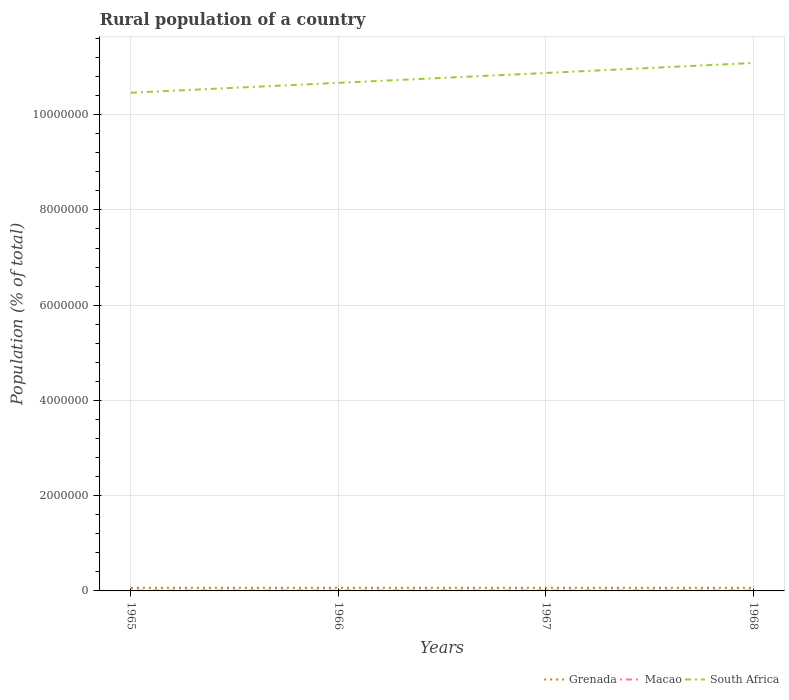How many different coloured lines are there?
Your answer should be very brief. 3. Across all years, what is the maximum rural population in South Africa?
Your answer should be compact. 1.05e+07. In which year was the rural population in South Africa maximum?
Make the answer very short. 1965. What is the total rural population in Grenada in the graph?
Ensure brevity in your answer.  366. What is the difference between the highest and the second highest rural population in Grenada?
Your response must be concise. 366. What is the difference between the highest and the lowest rural population in South Africa?
Provide a short and direct response. 2. Is the rural population in Macao strictly greater than the rural population in Grenada over the years?
Your answer should be very brief. Yes. What is the difference between two consecutive major ticks on the Y-axis?
Give a very brief answer. 2.00e+06. Are the values on the major ticks of Y-axis written in scientific E-notation?
Keep it short and to the point. No. Does the graph contain grids?
Your response must be concise. Yes. Where does the legend appear in the graph?
Your answer should be very brief. Bottom right. How are the legend labels stacked?
Make the answer very short. Horizontal. What is the title of the graph?
Give a very brief answer. Rural population of a country. Does "Sub-Saharan Africa (all income levels)" appear as one of the legend labels in the graph?
Your answer should be very brief. No. What is the label or title of the X-axis?
Offer a terse response. Years. What is the label or title of the Y-axis?
Your response must be concise. Population (% of total). What is the Population (% of total) of Grenada in 1965?
Keep it short and to the point. 6.50e+04. What is the Population (% of total) in Macao in 1965?
Make the answer very short. 7910. What is the Population (% of total) of South Africa in 1965?
Your response must be concise. 1.05e+07. What is the Population (% of total) in Grenada in 1966?
Keep it short and to the point. 6.50e+04. What is the Population (% of total) in Macao in 1966?
Keep it short and to the point. 7883. What is the Population (% of total) in South Africa in 1966?
Keep it short and to the point. 1.07e+07. What is the Population (% of total) of Grenada in 1967?
Provide a succinct answer. 6.49e+04. What is the Population (% of total) of Macao in 1967?
Give a very brief answer. 7854. What is the Population (% of total) of South Africa in 1967?
Your response must be concise. 1.09e+07. What is the Population (% of total) in Grenada in 1968?
Provide a short and direct response. 6.47e+04. What is the Population (% of total) of Macao in 1968?
Offer a very short reply. 7790. What is the Population (% of total) of South Africa in 1968?
Your answer should be very brief. 1.11e+07. Across all years, what is the maximum Population (% of total) of Grenada?
Provide a succinct answer. 6.50e+04. Across all years, what is the maximum Population (% of total) of Macao?
Keep it short and to the point. 7910. Across all years, what is the maximum Population (% of total) in South Africa?
Your response must be concise. 1.11e+07. Across all years, what is the minimum Population (% of total) of Grenada?
Keep it short and to the point. 6.47e+04. Across all years, what is the minimum Population (% of total) of Macao?
Offer a terse response. 7790. Across all years, what is the minimum Population (% of total) of South Africa?
Your response must be concise. 1.05e+07. What is the total Population (% of total) of Grenada in the graph?
Ensure brevity in your answer.  2.60e+05. What is the total Population (% of total) in Macao in the graph?
Your answer should be compact. 3.14e+04. What is the total Population (% of total) of South Africa in the graph?
Your answer should be very brief. 4.31e+07. What is the difference between the Population (% of total) in Grenada in 1965 and that in 1966?
Give a very brief answer. -25. What is the difference between the Population (% of total) in Macao in 1965 and that in 1966?
Offer a terse response. 27. What is the difference between the Population (% of total) of South Africa in 1965 and that in 1966?
Ensure brevity in your answer.  -2.07e+05. What is the difference between the Population (% of total) in Macao in 1965 and that in 1967?
Your answer should be compact. 56. What is the difference between the Population (% of total) in South Africa in 1965 and that in 1967?
Your answer should be compact. -4.15e+05. What is the difference between the Population (% of total) in Grenada in 1965 and that in 1968?
Offer a terse response. 341. What is the difference between the Population (% of total) in Macao in 1965 and that in 1968?
Your answer should be compact. 120. What is the difference between the Population (% of total) of South Africa in 1965 and that in 1968?
Provide a short and direct response. -6.25e+05. What is the difference between the Population (% of total) in Grenada in 1966 and that in 1967?
Your answer should be compact. 124. What is the difference between the Population (% of total) of Macao in 1966 and that in 1967?
Make the answer very short. 29. What is the difference between the Population (% of total) in South Africa in 1966 and that in 1967?
Offer a very short reply. -2.07e+05. What is the difference between the Population (% of total) in Grenada in 1966 and that in 1968?
Provide a short and direct response. 366. What is the difference between the Population (% of total) of Macao in 1966 and that in 1968?
Your response must be concise. 93. What is the difference between the Population (% of total) of South Africa in 1966 and that in 1968?
Your answer should be compact. -4.18e+05. What is the difference between the Population (% of total) of Grenada in 1967 and that in 1968?
Your answer should be very brief. 242. What is the difference between the Population (% of total) in Macao in 1967 and that in 1968?
Your answer should be very brief. 64. What is the difference between the Population (% of total) of South Africa in 1967 and that in 1968?
Ensure brevity in your answer.  -2.10e+05. What is the difference between the Population (% of total) in Grenada in 1965 and the Population (% of total) in Macao in 1966?
Your answer should be compact. 5.71e+04. What is the difference between the Population (% of total) in Grenada in 1965 and the Population (% of total) in South Africa in 1966?
Provide a short and direct response. -1.06e+07. What is the difference between the Population (% of total) of Macao in 1965 and the Population (% of total) of South Africa in 1966?
Make the answer very short. -1.07e+07. What is the difference between the Population (% of total) in Grenada in 1965 and the Population (% of total) in Macao in 1967?
Your answer should be very brief. 5.71e+04. What is the difference between the Population (% of total) of Grenada in 1965 and the Population (% of total) of South Africa in 1967?
Make the answer very short. -1.08e+07. What is the difference between the Population (% of total) of Macao in 1965 and the Population (% of total) of South Africa in 1967?
Make the answer very short. -1.09e+07. What is the difference between the Population (% of total) in Grenada in 1965 and the Population (% of total) in Macao in 1968?
Give a very brief answer. 5.72e+04. What is the difference between the Population (% of total) in Grenada in 1965 and the Population (% of total) in South Africa in 1968?
Make the answer very short. -1.10e+07. What is the difference between the Population (% of total) of Macao in 1965 and the Population (% of total) of South Africa in 1968?
Provide a short and direct response. -1.11e+07. What is the difference between the Population (% of total) in Grenada in 1966 and the Population (% of total) in Macao in 1967?
Provide a short and direct response. 5.72e+04. What is the difference between the Population (% of total) in Grenada in 1966 and the Population (% of total) in South Africa in 1967?
Your answer should be compact. -1.08e+07. What is the difference between the Population (% of total) of Macao in 1966 and the Population (% of total) of South Africa in 1967?
Provide a short and direct response. -1.09e+07. What is the difference between the Population (% of total) in Grenada in 1966 and the Population (% of total) in Macao in 1968?
Give a very brief answer. 5.72e+04. What is the difference between the Population (% of total) in Grenada in 1966 and the Population (% of total) in South Africa in 1968?
Your response must be concise. -1.10e+07. What is the difference between the Population (% of total) of Macao in 1966 and the Population (% of total) of South Africa in 1968?
Provide a succinct answer. -1.11e+07. What is the difference between the Population (% of total) of Grenada in 1967 and the Population (% of total) of Macao in 1968?
Your response must be concise. 5.71e+04. What is the difference between the Population (% of total) in Grenada in 1967 and the Population (% of total) in South Africa in 1968?
Your response must be concise. -1.10e+07. What is the difference between the Population (% of total) in Macao in 1967 and the Population (% of total) in South Africa in 1968?
Provide a short and direct response. -1.11e+07. What is the average Population (% of total) of Grenada per year?
Keep it short and to the point. 6.49e+04. What is the average Population (% of total) in Macao per year?
Your answer should be compact. 7859.25. What is the average Population (% of total) of South Africa per year?
Make the answer very short. 1.08e+07. In the year 1965, what is the difference between the Population (% of total) in Grenada and Population (% of total) in Macao?
Your answer should be very brief. 5.71e+04. In the year 1965, what is the difference between the Population (% of total) of Grenada and Population (% of total) of South Africa?
Your response must be concise. -1.04e+07. In the year 1965, what is the difference between the Population (% of total) in Macao and Population (% of total) in South Africa?
Ensure brevity in your answer.  -1.05e+07. In the year 1966, what is the difference between the Population (% of total) of Grenada and Population (% of total) of Macao?
Offer a terse response. 5.71e+04. In the year 1966, what is the difference between the Population (% of total) of Grenada and Population (% of total) of South Africa?
Keep it short and to the point. -1.06e+07. In the year 1966, what is the difference between the Population (% of total) of Macao and Population (% of total) of South Africa?
Your answer should be compact. -1.07e+07. In the year 1967, what is the difference between the Population (% of total) of Grenada and Population (% of total) of Macao?
Your answer should be very brief. 5.70e+04. In the year 1967, what is the difference between the Population (% of total) of Grenada and Population (% of total) of South Africa?
Your answer should be very brief. -1.08e+07. In the year 1967, what is the difference between the Population (% of total) in Macao and Population (% of total) in South Africa?
Make the answer very short. -1.09e+07. In the year 1968, what is the difference between the Population (% of total) of Grenada and Population (% of total) of Macao?
Offer a terse response. 5.69e+04. In the year 1968, what is the difference between the Population (% of total) in Grenada and Population (% of total) in South Africa?
Provide a succinct answer. -1.10e+07. In the year 1968, what is the difference between the Population (% of total) of Macao and Population (% of total) of South Africa?
Your response must be concise. -1.11e+07. What is the ratio of the Population (% of total) of Grenada in 1965 to that in 1966?
Offer a very short reply. 1. What is the ratio of the Population (% of total) in South Africa in 1965 to that in 1966?
Your response must be concise. 0.98. What is the ratio of the Population (% of total) in Grenada in 1965 to that in 1967?
Give a very brief answer. 1. What is the ratio of the Population (% of total) of Macao in 1965 to that in 1967?
Make the answer very short. 1.01. What is the ratio of the Population (% of total) in South Africa in 1965 to that in 1967?
Your response must be concise. 0.96. What is the ratio of the Population (% of total) in Macao in 1965 to that in 1968?
Keep it short and to the point. 1.02. What is the ratio of the Population (% of total) in South Africa in 1965 to that in 1968?
Your response must be concise. 0.94. What is the ratio of the Population (% of total) in South Africa in 1966 to that in 1967?
Keep it short and to the point. 0.98. What is the ratio of the Population (% of total) in Grenada in 1966 to that in 1968?
Keep it short and to the point. 1.01. What is the ratio of the Population (% of total) of Macao in 1966 to that in 1968?
Your answer should be very brief. 1.01. What is the ratio of the Population (% of total) in South Africa in 1966 to that in 1968?
Make the answer very short. 0.96. What is the ratio of the Population (% of total) in Macao in 1967 to that in 1968?
Offer a very short reply. 1.01. What is the difference between the highest and the second highest Population (% of total) in Grenada?
Provide a succinct answer. 25. What is the difference between the highest and the second highest Population (% of total) in South Africa?
Offer a terse response. 2.10e+05. What is the difference between the highest and the lowest Population (% of total) in Grenada?
Your answer should be compact. 366. What is the difference between the highest and the lowest Population (% of total) of Macao?
Give a very brief answer. 120. What is the difference between the highest and the lowest Population (% of total) in South Africa?
Provide a succinct answer. 6.25e+05. 